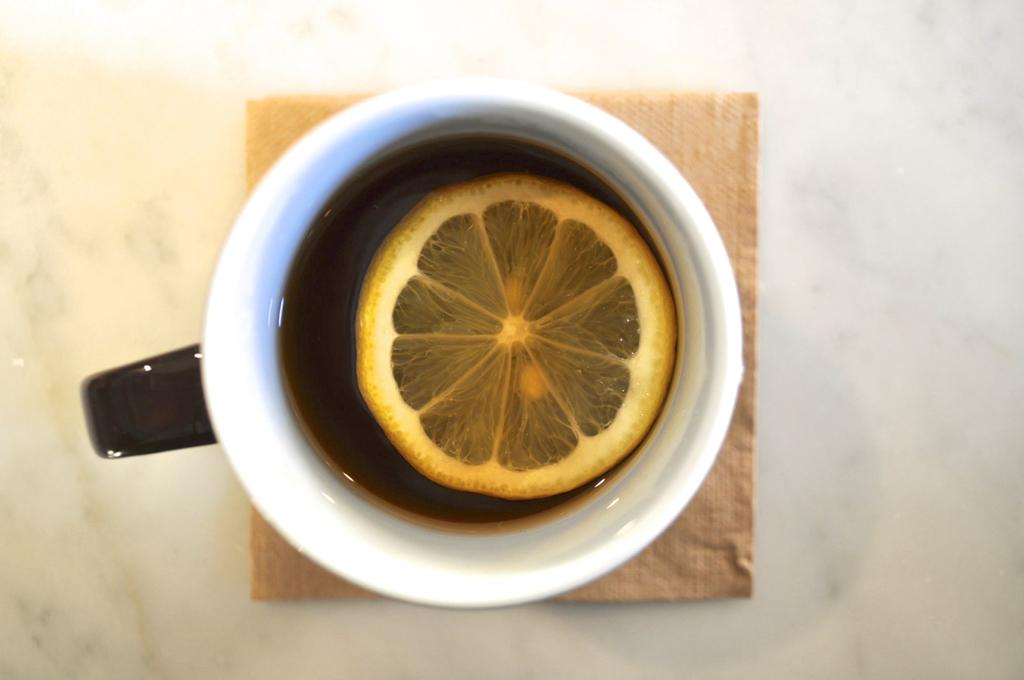What object is present in the image that is typically used for holding liquids? There is a cup in the image. What is the cup placed on? The cup is on a tissue. What is inside the cup? The cup contains a lemon. What type of farm animals can be seen grazing in the image? There are no farm animals present in the image. What type of engine can be seen powering a vehicle in the image? There are no engines or vehicles present in the image. 